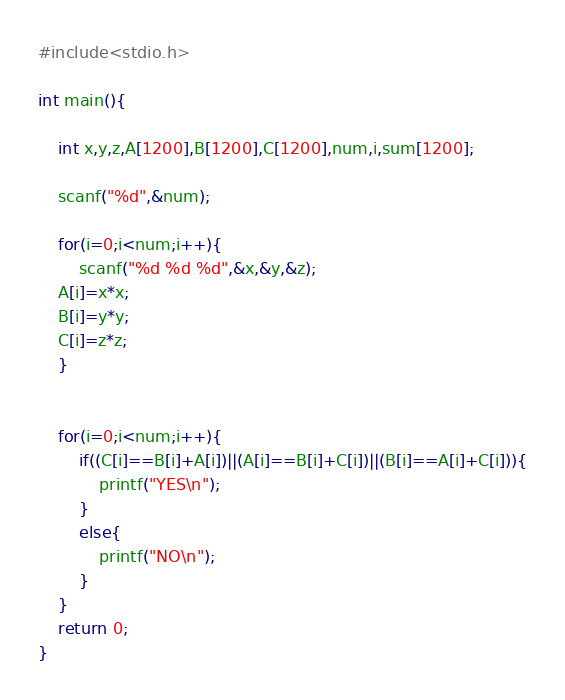Convert code to text. <code><loc_0><loc_0><loc_500><loc_500><_C_>#include<stdio.h>

int main(){
	
	int x,y,z,A[1200],B[1200],C[1200],num,i,sum[1200];
	
	scanf("%d",&num);
	
	for(i=0;i<num;i++){
		scanf("%d %d %d",&x,&y,&z);
	A[i]=x*x;
	B[i]=y*y;
	C[i]=z*z;
	}
	
	
	for(i=0;i<num;i++){
		if((C[i]==B[i]+A[i])||(A[i]==B[i]+C[i])||(B[i]==A[i]+C[i])){
			printf("YES\n");
		}
		else{
			printf("NO\n");
		}
	}
	return 0;
}</code> 